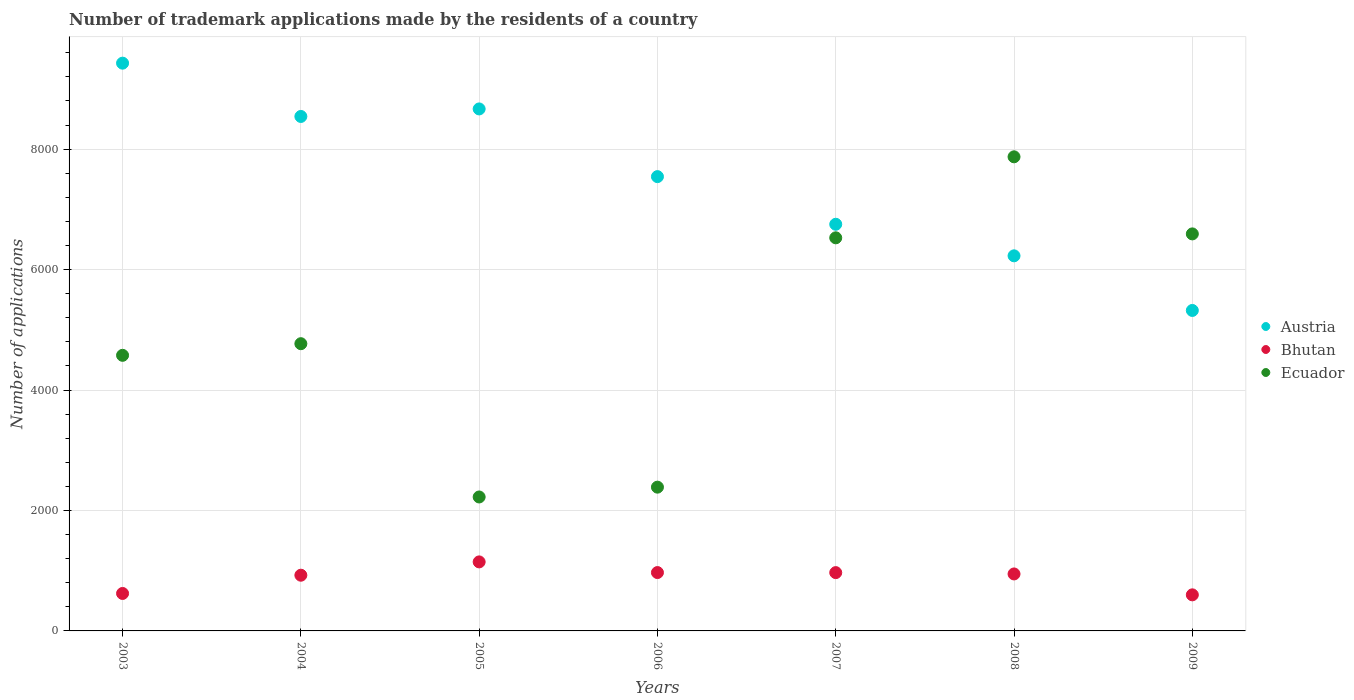What is the number of trademark applications made by the residents in Ecuador in 2006?
Offer a very short reply. 2387. Across all years, what is the maximum number of trademark applications made by the residents in Bhutan?
Your answer should be very brief. 1146. Across all years, what is the minimum number of trademark applications made by the residents in Austria?
Your answer should be compact. 5321. In which year was the number of trademark applications made by the residents in Austria minimum?
Provide a succinct answer. 2009. What is the total number of trademark applications made by the residents in Austria in the graph?
Offer a very short reply. 5.25e+04. What is the difference between the number of trademark applications made by the residents in Austria in 2003 and that in 2008?
Keep it short and to the point. 3199. What is the difference between the number of trademark applications made by the residents in Ecuador in 2006 and the number of trademark applications made by the residents in Austria in 2009?
Your answer should be compact. -2934. What is the average number of trademark applications made by the residents in Bhutan per year?
Provide a succinct answer. 882.14. In the year 2005, what is the difference between the number of trademark applications made by the residents in Ecuador and number of trademark applications made by the residents in Austria?
Your response must be concise. -6443. What is the ratio of the number of trademark applications made by the residents in Ecuador in 2003 to that in 2004?
Your answer should be compact. 0.96. Is the number of trademark applications made by the residents in Bhutan in 2007 less than that in 2008?
Your answer should be very brief. No. Is the difference between the number of trademark applications made by the residents in Ecuador in 2003 and 2007 greater than the difference between the number of trademark applications made by the residents in Austria in 2003 and 2007?
Offer a very short reply. No. What is the difference between the highest and the second highest number of trademark applications made by the residents in Austria?
Offer a terse response. 760. What is the difference between the highest and the lowest number of trademark applications made by the residents in Bhutan?
Your answer should be very brief. 547. In how many years, is the number of trademark applications made by the residents in Bhutan greater than the average number of trademark applications made by the residents in Bhutan taken over all years?
Give a very brief answer. 5. Is it the case that in every year, the sum of the number of trademark applications made by the residents in Ecuador and number of trademark applications made by the residents in Austria  is greater than the number of trademark applications made by the residents in Bhutan?
Provide a succinct answer. Yes. How many dotlines are there?
Make the answer very short. 3. How many years are there in the graph?
Give a very brief answer. 7. What is the difference between two consecutive major ticks on the Y-axis?
Provide a succinct answer. 2000. Are the values on the major ticks of Y-axis written in scientific E-notation?
Your answer should be very brief. No. Where does the legend appear in the graph?
Offer a very short reply. Center right. How are the legend labels stacked?
Offer a terse response. Vertical. What is the title of the graph?
Give a very brief answer. Number of trademark applications made by the residents of a country. What is the label or title of the Y-axis?
Give a very brief answer. Number of applications. What is the Number of applications in Austria in 2003?
Give a very brief answer. 9427. What is the Number of applications in Bhutan in 2003?
Provide a short and direct response. 622. What is the Number of applications in Ecuador in 2003?
Make the answer very short. 4576. What is the Number of applications of Austria in 2004?
Keep it short and to the point. 8542. What is the Number of applications in Bhutan in 2004?
Provide a short and direct response. 925. What is the Number of applications of Ecuador in 2004?
Provide a short and direct response. 4769. What is the Number of applications of Austria in 2005?
Your answer should be very brief. 8667. What is the Number of applications of Bhutan in 2005?
Offer a terse response. 1146. What is the Number of applications in Ecuador in 2005?
Ensure brevity in your answer.  2224. What is the Number of applications in Austria in 2006?
Offer a very short reply. 7543. What is the Number of applications in Bhutan in 2006?
Provide a short and direct response. 969. What is the Number of applications of Ecuador in 2006?
Your answer should be very brief. 2387. What is the Number of applications of Austria in 2007?
Ensure brevity in your answer.  6752. What is the Number of applications in Bhutan in 2007?
Offer a terse response. 968. What is the Number of applications of Ecuador in 2007?
Your response must be concise. 6527. What is the Number of applications in Austria in 2008?
Your answer should be compact. 6228. What is the Number of applications of Bhutan in 2008?
Your response must be concise. 946. What is the Number of applications of Ecuador in 2008?
Keep it short and to the point. 7872. What is the Number of applications of Austria in 2009?
Give a very brief answer. 5321. What is the Number of applications of Bhutan in 2009?
Give a very brief answer. 599. What is the Number of applications of Ecuador in 2009?
Ensure brevity in your answer.  6592. Across all years, what is the maximum Number of applications of Austria?
Provide a succinct answer. 9427. Across all years, what is the maximum Number of applications in Bhutan?
Your answer should be compact. 1146. Across all years, what is the maximum Number of applications of Ecuador?
Make the answer very short. 7872. Across all years, what is the minimum Number of applications in Austria?
Offer a very short reply. 5321. Across all years, what is the minimum Number of applications of Bhutan?
Make the answer very short. 599. Across all years, what is the minimum Number of applications of Ecuador?
Make the answer very short. 2224. What is the total Number of applications in Austria in the graph?
Your response must be concise. 5.25e+04. What is the total Number of applications of Bhutan in the graph?
Ensure brevity in your answer.  6175. What is the total Number of applications in Ecuador in the graph?
Your answer should be compact. 3.49e+04. What is the difference between the Number of applications of Austria in 2003 and that in 2004?
Your response must be concise. 885. What is the difference between the Number of applications in Bhutan in 2003 and that in 2004?
Your answer should be very brief. -303. What is the difference between the Number of applications of Ecuador in 2003 and that in 2004?
Your response must be concise. -193. What is the difference between the Number of applications in Austria in 2003 and that in 2005?
Your answer should be very brief. 760. What is the difference between the Number of applications of Bhutan in 2003 and that in 2005?
Keep it short and to the point. -524. What is the difference between the Number of applications in Ecuador in 2003 and that in 2005?
Offer a terse response. 2352. What is the difference between the Number of applications in Austria in 2003 and that in 2006?
Ensure brevity in your answer.  1884. What is the difference between the Number of applications in Bhutan in 2003 and that in 2006?
Keep it short and to the point. -347. What is the difference between the Number of applications in Ecuador in 2003 and that in 2006?
Make the answer very short. 2189. What is the difference between the Number of applications of Austria in 2003 and that in 2007?
Keep it short and to the point. 2675. What is the difference between the Number of applications in Bhutan in 2003 and that in 2007?
Ensure brevity in your answer.  -346. What is the difference between the Number of applications in Ecuador in 2003 and that in 2007?
Provide a succinct answer. -1951. What is the difference between the Number of applications in Austria in 2003 and that in 2008?
Offer a very short reply. 3199. What is the difference between the Number of applications in Bhutan in 2003 and that in 2008?
Make the answer very short. -324. What is the difference between the Number of applications of Ecuador in 2003 and that in 2008?
Ensure brevity in your answer.  -3296. What is the difference between the Number of applications of Austria in 2003 and that in 2009?
Make the answer very short. 4106. What is the difference between the Number of applications of Bhutan in 2003 and that in 2009?
Your answer should be very brief. 23. What is the difference between the Number of applications in Ecuador in 2003 and that in 2009?
Ensure brevity in your answer.  -2016. What is the difference between the Number of applications of Austria in 2004 and that in 2005?
Keep it short and to the point. -125. What is the difference between the Number of applications of Bhutan in 2004 and that in 2005?
Keep it short and to the point. -221. What is the difference between the Number of applications in Ecuador in 2004 and that in 2005?
Provide a succinct answer. 2545. What is the difference between the Number of applications of Austria in 2004 and that in 2006?
Provide a succinct answer. 999. What is the difference between the Number of applications in Bhutan in 2004 and that in 2006?
Make the answer very short. -44. What is the difference between the Number of applications of Ecuador in 2004 and that in 2006?
Your response must be concise. 2382. What is the difference between the Number of applications of Austria in 2004 and that in 2007?
Your answer should be very brief. 1790. What is the difference between the Number of applications of Bhutan in 2004 and that in 2007?
Give a very brief answer. -43. What is the difference between the Number of applications in Ecuador in 2004 and that in 2007?
Your response must be concise. -1758. What is the difference between the Number of applications in Austria in 2004 and that in 2008?
Your answer should be compact. 2314. What is the difference between the Number of applications of Ecuador in 2004 and that in 2008?
Offer a terse response. -3103. What is the difference between the Number of applications in Austria in 2004 and that in 2009?
Make the answer very short. 3221. What is the difference between the Number of applications in Bhutan in 2004 and that in 2009?
Ensure brevity in your answer.  326. What is the difference between the Number of applications in Ecuador in 2004 and that in 2009?
Offer a very short reply. -1823. What is the difference between the Number of applications of Austria in 2005 and that in 2006?
Offer a terse response. 1124. What is the difference between the Number of applications in Bhutan in 2005 and that in 2006?
Your response must be concise. 177. What is the difference between the Number of applications in Ecuador in 2005 and that in 2006?
Your response must be concise. -163. What is the difference between the Number of applications in Austria in 2005 and that in 2007?
Ensure brevity in your answer.  1915. What is the difference between the Number of applications in Bhutan in 2005 and that in 2007?
Your response must be concise. 178. What is the difference between the Number of applications in Ecuador in 2005 and that in 2007?
Offer a very short reply. -4303. What is the difference between the Number of applications of Austria in 2005 and that in 2008?
Your answer should be compact. 2439. What is the difference between the Number of applications in Bhutan in 2005 and that in 2008?
Your answer should be very brief. 200. What is the difference between the Number of applications in Ecuador in 2005 and that in 2008?
Offer a terse response. -5648. What is the difference between the Number of applications of Austria in 2005 and that in 2009?
Offer a terse response. 3346. What is the difference between the Number of applications of Bhutan in 2005 and that in 2009?
Keep it short and to the point. 547. What is the difference between the Number of applications in Ecuador in 2005 and that in 2009?
Your response must be concise. -4368. What is the difference between the Number of applications of Austria in 2006 and that in 2007?
Provide a short and direct response. 791. What is the difference between the Number of applications of Ecuador in 2006 and that in 2007?
Offer a very short reply. -4140. What is the difference between the Number of applications of Austria in 2006 and that in 2008?
Ensure brevity in your answer.  1315. What is the difference between the Number of applications in Bhutan in 2006 and that in 2008?
Keep it short and to the point. 23. What is the difference between the Number of applications in Ecuador in 2006 and that in 2008?
Offer a terse response. -5485. What is the difference between the Number of applications in Austria in 2006 and that in 2009?
Your answer should be compact. 2222. What is the difference between the Number of applications in Bhutan in 2006 and that in 2009?
Your answer should be compact. 370. What is the difference between the Number of applications of Ecuador in 2006 and that in 2009?
Provide a succinct answer. -4205. What is the difference between the Number of applications of Austria in 2007 and that in 2008?
Ensure brevity in your answer.  524. What is the difference between the Number of applications in Bhutan in 2007 and that in 2008?
Your response must be concise. 22. What is the difference between the Number of applications in Ecuador in 2007 and that in 2008?
Your answer should be compact. -1345. What is the difference between the Number of applications in Austria in 2007 and that in 2009?
Give a very brief answer. 1431. What is the difference between the Number of applications of Bhutan in 2007 and that in 2009?
Make the answer very short. 369. What is the difference between the Number of applications of Ecuador in 2007 and that in 2009?
Ensure brevity in your answer.  -65. What is the difference between the Number of applications in Austria in 2008 and that in 2009?
Provide a succinct answer. 907. What is the difference between the Number of applications of Bhutan in 2008 and that in 2009?
Provide a succinct answer. 347. What is the difference between the Number of applications of Ecuador in 2008 and that in 2009?
Ensure brevity in your answer.  1280. What is the difference between the Number of applications of Austria in 2003 and the Number of applications of Bhutan in 2004?
Your response must be concise. 8502. What is the difference between the Number of applications in Austria in 2003 and the Number of applications in Ecuador in 2004?
Offer a terse response. 4658. What is the difference between the Number of applications of Bhutan in 2003 and the Number of applications of Ecuador in 2004?
Provide a succinct answer. -4147. What is the difference between the Number of applications in Austria in 2003 and the Number of applications in Bhutan in 2005?
Keep it short and to the point. 8281. What is the difference between the Number of applications in Austria in 2003 and the Number of applications in Ecuador in 2005?
Offer a terse response. 7203. What is the difference between the Number of applications in Bhutan in 2003 and the Number of applications in Ecuador in 2005?
Your answer should be very brief. -1602. What is the difference between the Number of applications in Austria in 2003 and the Number of applications in Bhutan in 2006?
Provide a succinct answer. 8458. What is the difference between the Number of applications in Austria in 2003 and the Number of applications in Ecuador in 2006?
Your answer should be compact. 7040. What is the difference between the Number of applications of Bhutan in 2003 and the Number of applications of Ecuador in 2006?
Give a very brief answer. -1765. What is the difference between the Number of applications of Austria in 2003 and the Number of applications of Bhutan in 2007?
Your answer should be very brief. 8459. What is the difference between the Number of applications of Austria in 2003 and the Number of applications of Ecuador in 2007?
Your answer should be compact. 2900. What is the difference between the Number of applications of Bhutan in 2003 and the Number of applications of Ecuador in 2007?
Offer a very short reply. -5905. What is the difference between the Number of applications in Austria in 2003 and the Number of applications in Bhutan in 2008?
Give a very brief answer. 8481. What is the difference between the Number of applications of Austria in 2003 and the Number of applications of Ecuador in 2008?
Make the answer very short. 1555. What is the difference between the Number of applications of Bhutan in 2003 and the Number of applications of Ecuador in 2008?
Your response must be concise. -7250. What is the difference between the Number of applications in Austria in 2003 and the Number of applications in Bhutan in 2009?
Provide a short and direct response. 8828. What is the difference between the Number of applications in Austria in 2003 and the Number of applications in Ecuador in 2009?
Provide a short and direct response. 2835. What is the difference between the Number of applications of Bhutan in 2003 and the Number of applications of Ecuador in 2009?
Ensure brevity in your answer.  -5970. What is the difference between the Number of applications in Austria in 2004 and the Number of applications in Bhutan in 2005?
Your response must be concise. 7396. What is the difference between the Number of applications in Austria in 2004 and the Number of applications in Ecuador in 2005?
Your answer should be compact. 6318. What is the difference between the Number of applications in Bhutan in 2004 and the Number of applications in Ecuador in 2005?
Keep it short and to the point. -1299. What is the difference between the Number of applications of Austria in 2004 and the Number of applications of Bhutan in 2006?
Provide a short and direct response. 7573. What is the difference between the Number of applications in Austria in 2004 and the Number of applications in Ecuador in 2006?
Offer a terse response. 6155. What is the difference between the Number of applications in Bhutan in 2004 and the Number of applications in Ecuador in 2006?
Ensure brevity in your answer.  -1462. What is the difference between the Number of applications of Austria in 2004 and the Number of applications of Bhutan in 2007?
Your response must be concise. 7574. What is the difference between the Number of applications in Austria in 2004 and the Number of applications in Ecuador in 2007?
Keep it short and to the point. 2015. What is the difference between the Number of applications of Bhutan in 2004 and the Number of applications of Ecuador in 2007?
Ensure brevity in your answer.  -5602. What is the difference between the Number of applications in Austria in 2004 and the Number of applications in Bhutan in 2008?
Offer a terse response. 7596. What is the difference between the Number of applications in Austria in 2004 and the Number of applications in Ecuador in 2008?
Your answer should be compact. 670. What is the difference between the Number of applications in Bhutan in 2004 and the Number of applications in Ecuador in 2008?
Ensure brevity in your answer.  -6947. What is the difference between the Number of applications in Austria in 2004 and the Number of applications in Bhutan in 2009?
Offer a terse response. 7943. What is the difference between the Number of applications of Austria in 2004 and the Number of applications of Ecuador in 2009?
Keep it short and to the point. 1950. What is the difference between the Number of applications in Bhutan in 2004 and the Number of applications in Ecuador in 2009?
Give a very brief answer. -5667. What is the difference between the Number of applications in Austria in 2005 and the Number of applications in Bhutan in 2006?
Provide a short and direct response. 7698. What is the difference between the Number of applications of Austria in 2005 and the Number of applications of Ecuador in 2006?
Provide a succinct answer. 6280. What is the difference between the Number of applications in Bhutan in 2005 and the Number of applications in Ecuador in 2006?
Offer a very short reply. -1241. What is the difference between the Number of applications in Austria in 2005 and the Number of applications in Bhutan in 2007?
Provide a succinct answer. 7699. What is the difference between the Number of applications of Austria in 2005 and the Number of applications of Ecuador in 2007?
Make the answer very short. 2140. What is the difference between the Number of applications in Bhutan in 2005 and the Number of applications in Ecuador in 2007?
Give a very brief answer. -5381. What is the difference between the Number of applications of Austria in 2005 and the Number of applications of Bhutan in 2008?
Give a very brief answer. 7721. What is the difference between the Number of applications of Austria in 2005 and the Number of applications of Ecuador in 2008?
Your response must be concise. 795. What is the difference between the Number of applications of Bhutan in 2005 and the Number of applications of Ecuador in 2008?
Ensure brevity in your answer.  -6726. What is the difference between the Number of applications of Austria in 2005 and the Number of applications of Bhutan in 2009?
Provide a succinct answer. 8068. What is the difference between the Number of applications of Austria in 2005 and the Number of applications of Ecuador in 2009?
Keep it short and to the point. 2075. What is the difference between the Number of applications of Bhutan in 2005 and the Number of applications of Ecuador in 2009?
Give a very brief answer. -5446. What is the difference between the Number of applications of Austria in 2006 and the Number of applications of Bhutan in 2007?
Provide a succinct answer. 6575. What is the difference between the Number of applications of Austria in 2006 and the Number of applications of Ecuador in 2007?
Your response must be concise. 1016. What is the difference between the Number of applications of Bhutan in 2006 and the Number of applications of Ecuador in 2007?
Make the answer very short. -5558. What is the difference between the Number of applications in Austria in 2006 and the Number of applications in Bhutan in 2008?
Give a very brief answer. 6597. What is the difference between the Number of applications in Austria in 2006 and the Number of applications in Ecuador in 2008?
Offer a terse response. -329. What is the difference between the Number of applications in Bhutan in 2006 and the Number of applications in Ecuador in 2008?
Your response must be concise. -6903. What is the difference between the Number of applications in Austria in 2006 and the Number of applications in Bhutan in 2009?
Offer a very short reply. 6944. What is the difference between the Number of applications in Austria in 2006 and the Number of applications in Ecuador in 2009?
Your response must be concise. 951. What is the difference between the Number of applications of Bhutan in 2006 and the Number of applications of Ecuador in 2009?
Keep it short and to the point. -5623. What is the difference between the Number of applications in Austria in 2007 and the Number of applications in Bhutan in 2008?
Give a very brief answer. 5806. What is the difference between the Number of applications of Austria in 2007 and the Number of applications of Ecuador in 2008?
Provide a short and direct response. -1120. What is the difference between the Number of applications in Bhutan in 2007 and the Number of applications in Ecuador in 2008?
Provide a succinct answer. -6904. What is the difference between the Number of applications of Austria in 2007 and the Number of applications of Bhutan in 2009?
Provide a succinct answer. 6153. What is the difference between the Number of applications in Austria in 2007 and the Number of applications in Ecuador in 2009?
Provide a short and direct response. 160. What is the difference between the Number of applications of Bhutan in 2007 and the Number of applications of Ecuador in 2009?
Provide a succinct answer. -5624. What is the difference between the Number of applications in Austria in 2008 and the Number of applications in Bhutan in 2009?
Provide a succinct answer. 5629. What is the difference between the Number of applications in Austria in 2008 and the Number of applications in Ecuador in 2009?
Offer a terse response. -364. What is the difference between the Number of applications of Bhutan in 2008 and the Number of applications of Ecuador in 2009?
Ensure brevity in your answer.  -5646. What is the average Number of applications in Austria per year?
Keep it short and to the point. 7497.14. What is the average Number of applications of Bhutan per year?
Make the answer very short. 882.14. What is the average Number of applications in Ecuador per year?
Ensure brevity in your answer.  4992.43. In the year 2003, what is the difference between the Number of applications of Austria and Number of applications of Bhutan?
Ensure brevity in your answer.  8805. In the year 2003, what is the difference between the Number of applications in Austria and Number of applications in Ecuador?
Your answer should be very brief. 4851. In the year 2003, what is the difference between the Number of applications of Bhutan and Number of applications of Ecuador?
Give a very brief answer. -3954. In the year 2004, what is the difference between the Number of applications in Austria and Number of applications in Bhutan?
Offer a very short reply. 7617. In the year 2004, what is the difference between the Number of applications in Austria and Number of applications in Ecuador?
Make the answer very short. 3773. In the year 2004, what is the difference between the Number of applications of Bhutan and Number of applications of Ecuador?
Provide a short and direct response. -3844. In the year 2005, what is the difference between the Number of applications in Austria and Number of applications in Bhutan?
Provide a succinct answer. 7521. In the year 2005, what is the difference between the Number of applications of Austria and Number of applications of Ecuador?
Keep it short and to the point. 6443. In the year 2005, what is the difference between the Number of applications in Bhutan and Number of applications in Ecuador?
Offer a very short reply. -1078. In the year 2006, what is the difference between the Number of applications of Austria and Number of applications of Bhutan?
Give a very brief answer. 6574. In the year 2006, what is the difference between the Number of applications of Austria and Number of applications of Ecuador?
Keep it short and to the point. 5156. In the year 2006, what is the difference between the Number of applications in Bhutan and Number of applications in Ecuador?
Provide a succinct answer. -1418. In the year 2007, what is the difference between the Number of applications of Austria and Number of applications of Bhutan?
Provide a short and direct response. 5784. In the year 2007, what is the difference between the Number of applications of Austria and Number of applications of Ecuador?
Your response must be concise. 225. In the year 2007, what is the difference between the Number of applications of Bhutan and Number of applications of Ecuador?
Offer a terse response. -5559. In the year 2008, what is the difference between the Number of applications in Austria and Number of applications in Bhutan?
Provide a short and direct response. 5282. In the year 2008, what is the difference between the Number of applications in Austria and Number of applications in Ecuador?
Ensure brevity in your answer.  -1644. In the year 2008, what is the difference between the Number of applications in Bhutan and Number of applications in Ecuador?
Provide a succinct answer. -6926. In the year 2009, what is the difference between the Number of applications of Austria and Number of applications of Bhutan?
Keep it short and to the point. 4722. In the year 2009, what is the difference between the Number of applications of Austria and Number of applications of Ecuador?
Offer a terse response. -1271. In the year 2009, what is the difference between the Number of applications of Bhutan and Number of applications of Ecuador?
Keep it short and to the point. -5993. What is the ratio of the Number of applications of Austria in 2003 to that in 2004?
Keep it short and to the point. 1.1. What is the ratio of the Number of applications of Bhutan in 2003 to that in 2004?
Make the answer very short. 0.67. What is the ratio of the Number of applications of Ecuador in 2003 to that in 2004?
Provide a short and direct response. 0.96. What is the ratio of the Number of applications of Austria in 2003 to that in 2005?
Make the answer very short. 1.09. What is the ratio of the Number of applications in Bhutan in 2003 to that in 2005?
Keep it short and to the point. 0.54. What is the ratio of the Number of applications of Ecuador in 2003 to that in 2005?
Offer a very short reply. 2.06. What is the ratio of the Number of applications in Austria in 2003 to that in 2006?
Your response must be concise. 1.25. What is the ratio of the Number of applications in Bhutan in 2003 to that in 2006?
Offer a very short reply. 0.64. What is the ratio of the Number of applications in Ecuador in 2003 to that in 2006?
Make the answer very short. 1.92. What is the ratio of the Number of applications of Austria in 2003 to that in 2007?
Provide a succinct answer. 1.4. What is the ratio of the Number of applications of Bhutan in 2003 to that in 2007?
Ensure brevity in your answer.  0.64. What is the ratio of the Number of applications of Ecuador in 2003 to that in 2007?
Keep it short and to the point. 0.7. What is the ratio of the Number of applications of Austria in 2003 to that in 2008?
Provide a succinct answer. 1.51. What is the ratio of the Number of applications in Bhutan in 2003 to that in 2008?
Ensure brevity in your answer.  0.66. What is the ratio of the Number of applications of Ecuador in 2003 to that in 2008?
Offer a very short reply. 0.58. What is the ratio of the Number of applications of Austria in 2003 to that in 2009?
Provide a short and direct response. 1.77. What is the ratio of the Number of applications of Bhutan in 2003 to that in 2009?
Offer a very short reply. 1.04. What is the ratio of the Number of applications of Ecuador in 2003 to that in 2009?
Your answer should be compact. 0.69. What is the ratio of the Number of applications of Austria in 2004 to that in 2005?
Your answer should be very brief. 0.99. What is the ratio of the Number of applications of Bhutan in 2004 to that in 2005?
Offer a very short reply. 0.81. What is the ratio of the Number of applications of Ecuador in 2004 to that in 2005?
Keep it short and to the point. 2.14. What is the ratio of the Number of applications of Austria in 2004 to that in 2006?
Ensure brevity in your answer.  1.13. What is the ratio of the Number of applications in Bhutan in 2004 to that in 2006?
Your answer should be very brief. 0.95. What is the ratio of the Number of applications of Ecuador in 2004 to that in 2006?
Offer a terse response. 2. What is the ratio of the Number of applications in Austria in 2004 to that in 2007?
Offer a very short reply. 1.27. What is the ratio of the Number of applications in Bhutan in 2004 to that in 2007?
Ensure brevity in your answer.  0.96. What is the ratio of the Number of applications in Ecuador in 2004 to that in 2007?
Give a very brief answer. 0.73. What is the ratio of the Number of applications in Austria in 2004 to that in 2008?
Offer a terse response. 1.37. What is the ratio of the Number of applications of Bhutan in 2004 to that in 2008?
Your answer should be compact. 0.98. What is the ratio of the Number of applications of Ecuador in 2004 to that in 2008?
Your answer should be very brief. 0.61. What is the ratio of the Number of applications in Austria in 2004 to that in 2009?
Give a very brief answer. 1.61. What is the ratio of the Number of applications in Bhutan in 2004 to that in 2009?
Your answer should be compact. 1.54. What is the ratio of the Number of applications in Ecuador in 2004 to that in 2009?
Provide a short and direct response. 0.72. What is the ratio of the Number of applications in Austria in 2005 to that in 2006?
Give a very brief answer. 1.15. What is the ratio of the Number of applications in Bhutan in 2005 to that in 2006?
Give a very brief answer. 1.18. What is the ratio of the Number of applications of Ecuador in 2005 to that in 2006?
Your response must be concise. 0.93. What is the ratio of the Number of applications in Austria in 2005 to that in 2007?
Provide a short and direct response. 1.28. What is the ratio of the Number of applications of Bhutan in 2005 to that in 2007?
Give a very brief answer. 1.18. What is the ratio of the Number of applications in Ecuador in 2005 to that in 2007?
Keep it short and to the point. 0.34. What is the ratio of the Number of applications of Austria in 2005 to that in 2008?
Make the answer very short. 1.39. What is the ratio of the Number of applications in Bhutan in 2005 to that in 2008?
Your answer should be compact. 1.21. What is the ratio of the Number of applications in Ecuador in 2005 to that in 2008?
Your answer should be very brief. 0.28. What is the ratio of the Number of applications in Austria in 2005 to that in 2009?
Your response must be concise. 1.63. What is the ratio of the Number of applications of Bhutan in 2005 to that in 2009?
Provide a succinct answer. 1.91. What is the ratio of the Number of applications of Ecuador in 2005 to that in 2009?
Your answer should be very brief. 0.34. What is the ratio of the Number of applications in Austria in 2006 to that in 2007?
Keep it short and to the point. 1.12. What is the ratio of the Number of applications in Ecuador in 2006 to that in 2007?
Offer a very short reply. 0.37. What is the ratio of the Number of applications in Austria in 2006 to that in 2008?
Offer a terse response. 1.21. What is the ratio of the Number of applications in Bhutan in 2006 to that in 2008?
Provide a succinct answer. 1.02. What is the ratio of the Number of applications in Ecuador in 2006 to that in 2008?
Ensure brevity in your answer.  0.3. What is the ratio of the Number of applications of Austria in 2006 to that in 2009?
Ensure brevity in your answer.  1.42. What is the ratio of the Number of applications in Bhutan in 2006 to that in 2009?
Offer a very short reply. 1.62. What is the ratio of the Number of applications in Ecuador in 2006 to that in 2009?
Offer a very short reply. 0.36. What is the ratio of the Number of applications in Austria in 2007 to that in 2008?
Give a very brief answer. 1.08. What is the ratio of the Number of applications in Bhutan in 2007 to that in 2008?
Give a very brief answer. 1.02. What is the ratio of the Number of applications in Ecuador in 2007 to that in 2008?
Provide a succinct answer. 0.83. What is the ratio of the Number of applications of Austria in 2007 to that in 2009?
Ensure brevity in your answer.  1.27. What is the ratio of the Number of applications of Bhutan in 2007 to that in 2009?
Make the answer very short. 1.62. What is the ratio of the Number of applications in Ecuador in 2007 to that in 2009?
Keep it short and to the point. 0.99. What is the ratio of the Number of applications in Austria in 2008 to that in 2009?
Your answer should be very brief. 1.17. What is the ratio of the Number of applications in Bhutan in 2008 to that in 2009?
Your answer should be compact. 1.58. What is the ratio of the Number of applications of Ecuador in 2008 to that in 2009?
Your answer should be compact. 1.19. What is the difference between the highest and the second highest Number of applications of Austria?
Make the answer very short. 760. What is the difference between the highest and the second highest Number of applications of Bhutan?
Make the answer very short. 177. What is the difference between the highest and the second highest Number of applications in Ecuador?
Your response must be concise. 1280. What is the difference between the highest and the lowest Number of applications of Austria?
Ensure brevity in your answer.  4106. What is the difference between the highest and the lowest Number of applications in Bhutan?
Your answer should be very brief. 547. What is the difference between the highest and the lowest Number of applications of Ecuador?
Offer a very short reply. 5648. 